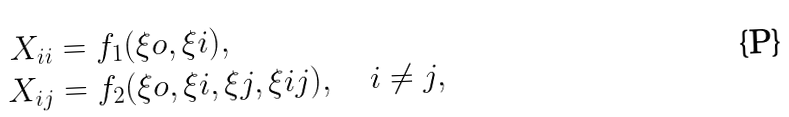<formula> <loc_0><loc_0><loc_500><loc_500>X _ { i i } & = f _ { 1 } ( \xi o , \xi i ) , \\ X _ { i j } & = f _ { 2 } ( \xi o , \xi i , \xi j , \xi i j ) , \quad i \neq j ,</formula> 